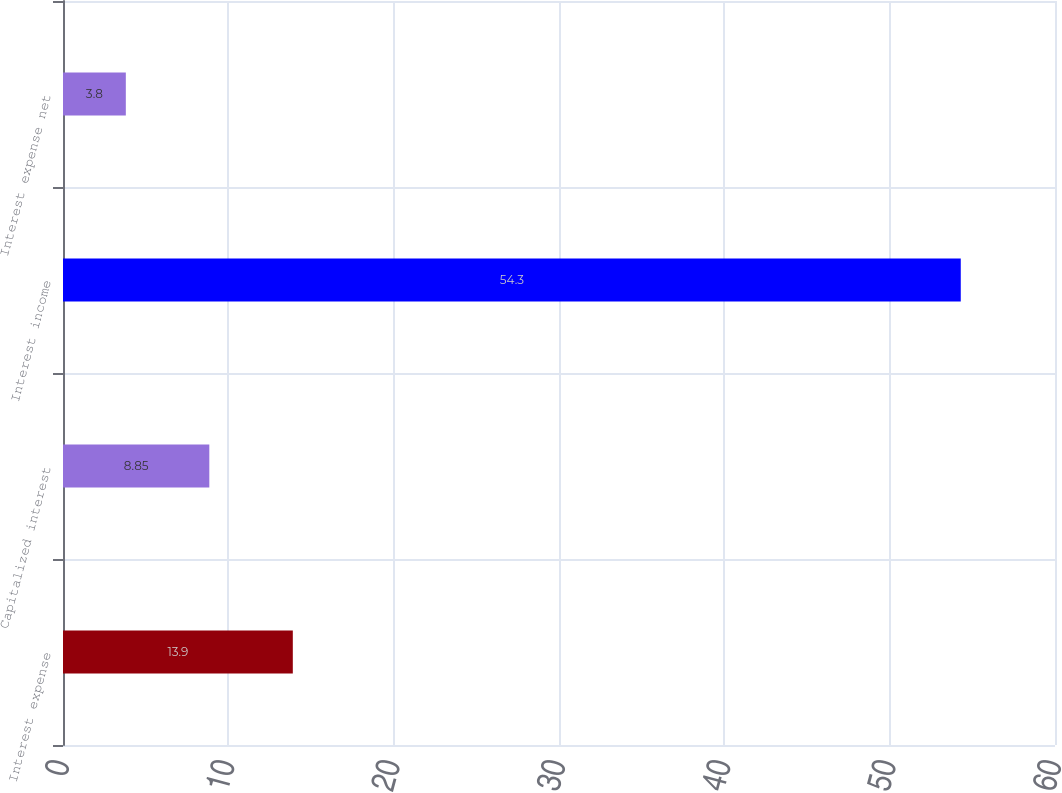Convert chart to OTSL. <chart><loc_0><loc_0><loc_500><loc_500><bar_chart><fcel>Interest expense<fcel>Capitalized interest<fcel>Interest income<fcel>Interest expense net<nl><fcel>13.9<fcel>8.85<fcel>54.3<fcel>3.8<nl></chart> 